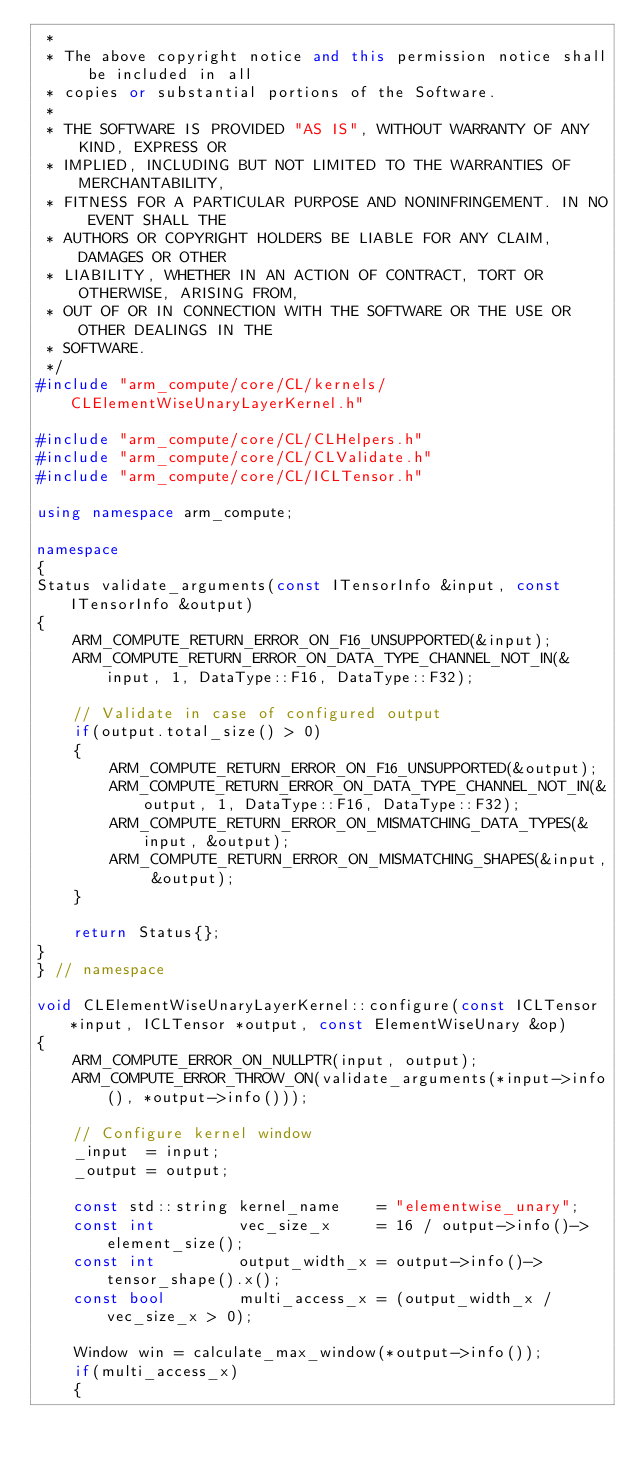<code> <loc_0><loc_0><loc_500><loc_500><_C++_> *
 * The above copyright notice and this permission notice shall be included in all
 * copies or substantial portions of the Software.
 *
 * THE SOFTWARE IS PROVIDED "AS IS", WITHOUT WARRANTY OF ANY KIND, EXPRESS OR
 * IMPLIED, INCLUDING BUT NOT LIMITED TO THE WARRANTIES OF MERCHANTABILITY,
 * FITNESS FOR A PARTICULAR PURPOSE AND NONINFRINGEMENT. IN NO EVENT SHALL THE
 * AUTHORS OR COPYRIGHT HOLDERS BE LIABLE FOR ANY CLAIM, DAMAGES OR OTHER
 * LIABILITY, WHETHER IN AN ACTION OF CONTRACT, TORT OR OTHERWISE, ARISING FROM,
 * OUT OF OR IN CONNECTION WITH THE SOFTWARE OR THE USE OR OTHER DEALINGS IN THE
 * SOFTWARE.
 */
#include "arm_compute/core/CL/kernels/CLElementWiseUnaryLayerKernel.h"

#include "arm_compute/core/CL/CLHelpers.h"
#include "arm_compute/core/CL/CLValidate.h"
#include "arm_compute/core/CL/ICLTensor.h"

using namespace arm_compute;

namespace
{
Status validate_arguments(const ITensorInfo &input, const ITensorInfo &output)
{
    ARM_COMPUTE_RETURN_ERROR_ON_F16_UNSUPPORTED(&input);
    ARM_COMPUTE_RETURN_ERROR_ON_DATA_TYPE_CHANNEL_NOT_IN(&input, 1, DataType::F16, DataType::F32);

    // Validate in case of configured output
    if(output.total_size() > 0)
    {
        ARM_COMPUTE_RETURN_ERROR_ON_F16_UNSUPPORTED(&output);
        ARM_COMPUTE_RETURN_ERROR_ON_DATA_TYPE_CHANNEL_NOT_IN(&output, 1, DataType::F16, DataType::F32);
        ARM_COMPUTE_RETURN_ERROR_ON_MISMATCHING_DATA_TYPES(&input, &output);
        ARM_COMPUTE_RETURN_ERROR_ON_MISMATCHING_SHAPES(&input, &output);
    }

    return Status{};
}
} // namespace

void CLElementWiseUnaryLayerKernel::configure(const ICLTensor *input, ICLTensor *output, const ElementWiseUnary &op)
{
    ARM_COMPUTE_ERROR_ON_NULLPTR(input, output);
    ARM_COMPUTE_ERROR_THROW_ON(validate_arguments(*input->info(), *output->info()));

    // Configure kernel window
    _input  = input;
    _output = output;

    const std::string kernel_name    = "elementwise_unary";
    const int         vec_size_x     = 16 / output->info()->element_size();
    const int         output_width_x = output->info()->tensor_shape().x();
    const bool        multi_access_x = (output_width_x / vec_size_x > 0);

    Window win = calculate_max_window(*output->info());
    if(multi_access_x)
    {</code> 